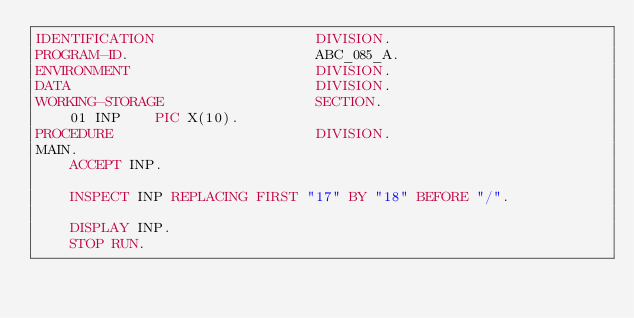Convert code to text. <code><loc_0><loc_0><loc_500><loc_500><_COBOL_>IDENTIFICATION                   DIVISION.
PROGRAM-ID.                      ABC_085_A.
ENVIRONMENT                      DIVISION.
DATA                             DIVISION.
WORKING-STORAGE                  SECTION.
    01 INP    PIC X(10).
PROCEDURE                        DIVISION.
MAIN.
    ACCEPT INP.

    INSPECT INP REPLACING FIRST "17" BY "18" BEFORE "/".

    DISPLAY INP.
    STOP RUN.
</code> 